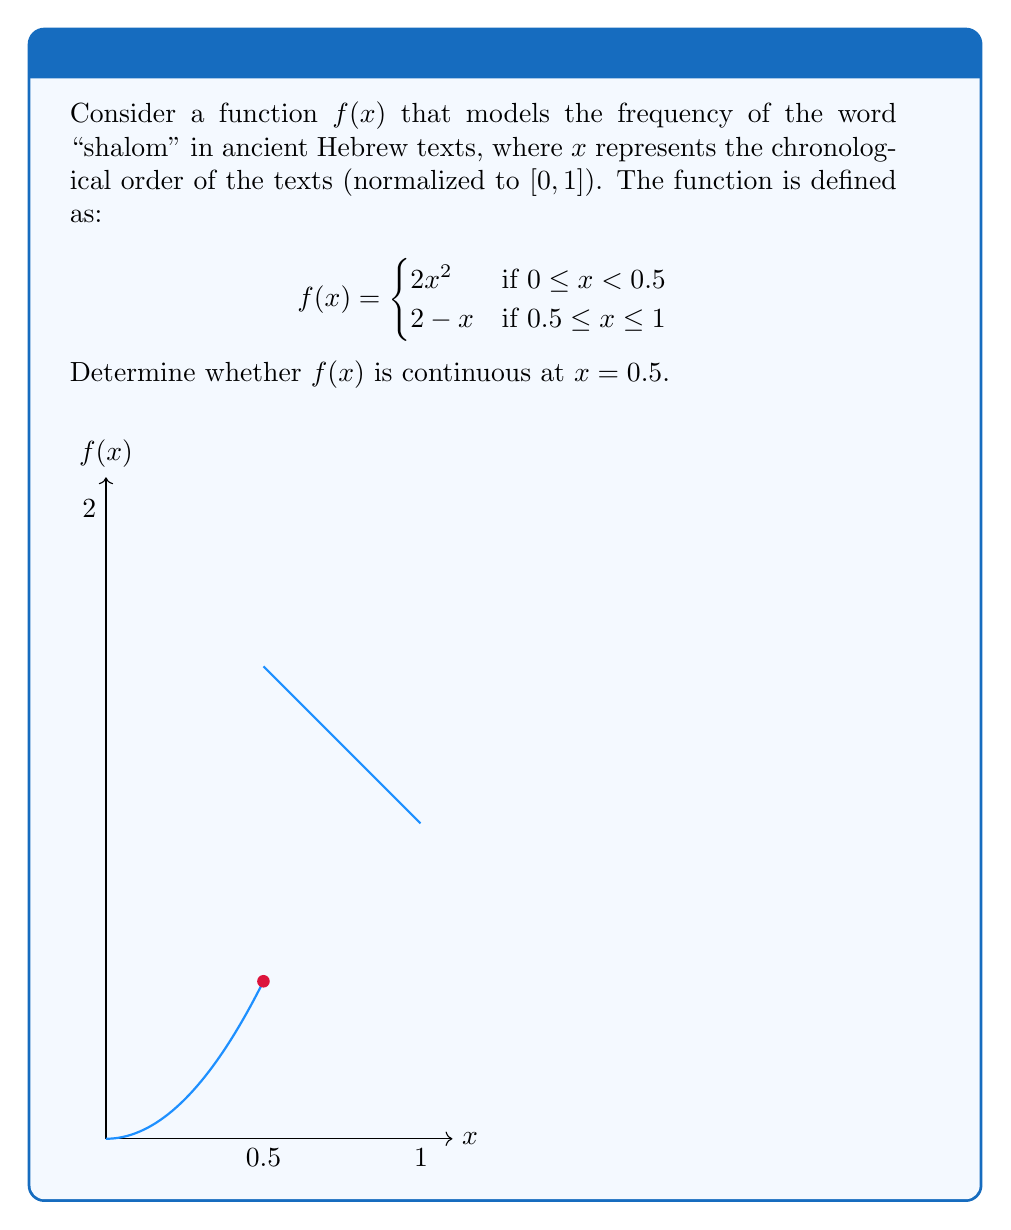Solve this math problem. To determine if $f(x)$ is continuous at $x = 0.5$, we need to check three conditions:

1. $f(0.5)$ exists
2. $\lim_{x \to 0.5^-} f(x)$ exists
3. $\lim_{x \to 0.5^+} f(x)$ exists
4. All three values are equal

Step 1: Evaluate $f(0.5)$
Using the second piece of the function:
$f(0.5) = 2 - 0.5 = 1.5$

Step 2: Evaluate $\lim_{x \to 0.5^-} f(x)$
Using the first piece of the function:
$\lim_{x \to 0.5^-} f(x) = \lim_{x \to 0.5^-} 2x^2 = 2(0.5)^2 = 0.5$

Step 3: Evaluate $\lim_{x \to 0.5^+} f(x)$
Using the second piece of the function:
$\lim_{x \to 0.5^+} f(x) = \lim_{x \to 0.5^+} (2-x) = 2 - 0.5 = 1.5$

Step 4: Compare the values
$f(0.5) = 1.5$
$\lim_{x \to 0.5^-} f(x) = 0.5$
$\lim_{x \to 0.5^+} f(x) = 1.5$

Since $\lim_{x \to 0.5^-} f(x) \neq \lim_{x \to 0.5^+} f(x)$, the function is not continuous at $x = 0.5$.
Answer: Not continuous at $x = 0.5$ 